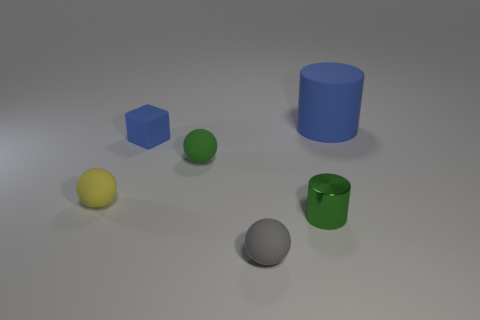Can you tell me what the surface looks like? The surface appears smooth and even, with a matte finish, displaying diffuse reflections and shadows from the objects. This could suggest a neutral-toned, non-reflective material like paper or a synthetic matte surface. 